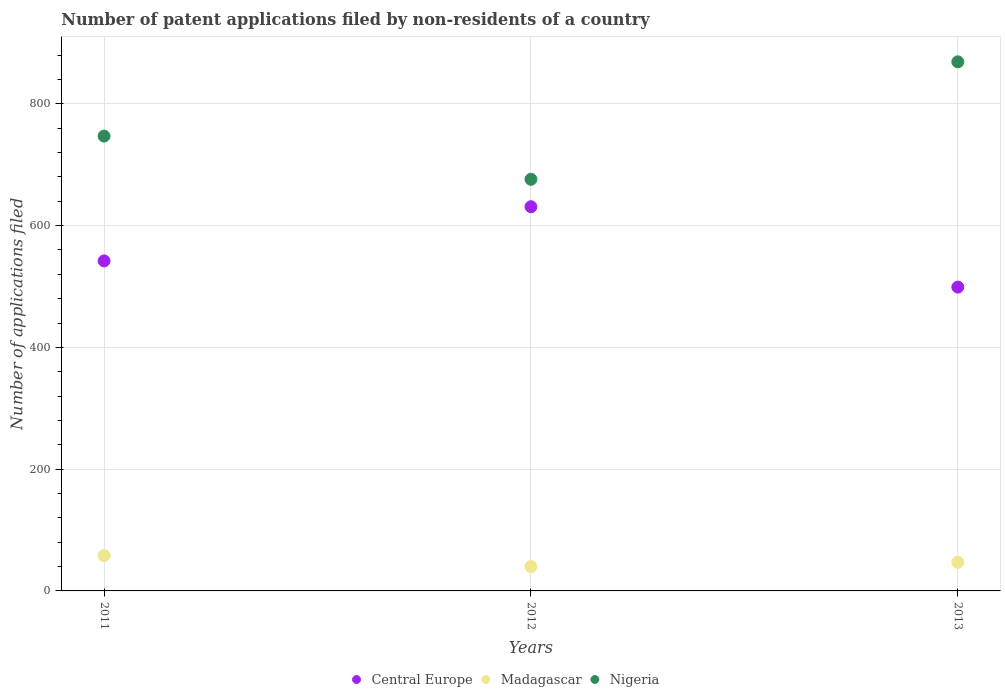How many different coloured dotlines are there?
Provide a succinct answer. 3. What is the number of applications filed in Madagascar in 2011?
Offer a terse response. 58. Across all years, what is the minimum number of applications filed in Nigeria?
Offer a terse response. 676. In which year was the number of applications filed in Nigeria minimum?
Your answer should be very brief. 2012. What is the total number of applications filed in Madagascar in the graph?
Offer a very short reply. 145. What is the difference between the number of applications filed in Madagascar in 2011 and that in 2013?
Offer a very short reply. 11. What is the difference between the number of applications filed in Nigeria in 2011 and the number of applications filed in Madagascar in 2013?
Your response must be concise. 700. What is the average number of applications filed in Central Europe per year?
Ensure brevity in your answer.  557.33. In the year 2013, what is the difference between the number of applications filed in Nigeria and number of applications filed in Central Europe?
Offer a terse response. 370. What is the ratio of the number of applications filed in Nigeria in 2011 to that in 2012?
Offer a terse response. 1.11. Is the number of applications filed in Central Europe in 2011 less than that in 2013?
Provide a succinct answer. No. What is the difference between the highest and the second highest number of applications filed in Nigeria?
Your answer should be very brief. 122. What is the difference between the highest and the lowest number of applications filed in Madagascar?
Offer a very short reply. 18. Is the sum of the number of applications filed in Madagascar in 2011 and 2012 greater than the maximum number of applications filed in Nigeria across all years?
Your answer should be compact. No. Is it the case that in every year, the sum of the number of applications filed in Nigeria and number of applications filed in Central Europe  is greater than the number of applications filed in Madagascar?
Your response must be concise. Yes. Does the number of applications filed in Nigeria monotonically increase over the years?
Provide a succinct answer. No. How many years are there in the graph?
Provide a succinct answer. 3. What is the difference between two consecutive major ticks on the Y-axis?
Offer a very short reply. 200. Does the graph contain grids?
Provide a succinct answer. Yes. Where does the legend appear in the graph?
Provide a succinct answer. Bottom center. How many legend labels are there?
Your response must be concise. 3. What is the title of the graph?
Keep it short and to the point. Number of patent applications filed by non-residents of a country. Does "Palau" appear as one of the legend labels in the graph?
Keep it short and to the point. No. What is the label or title of the Y-axis?
Provide a short and direct response. Number of applications filed. What is the Number of applications filed in Central Europe in 2011?
Offer a terse response. 542. What is the Number of applications filed in Madagascar in 2011?
Ensure brevity in your answer.  58. What is the Number of applications filed in Nigeria in 2011?
Your answer should be very brief. 747. What is the Number of applications filed in Central Europe in 2012?
Give a very brief answer. 631. What is the Number of applications filed in Madagascar in 2012?
Provide a succinct answer. 40. What is the Number of applications filed in Nigeria in 2012?
Your response must be concise. 676. What is the Number of applications filed in Central Europe in 2013?
Your answer should be very brief. 499. What is the Number of applications filed in Nigeria in 2013?
Your answer should be compact. 869. Across all years, what is the maximum Number of applications filed in Central Europe?
Provide a short and direct response. 631. Across all years, what is the maximum Number of applications filed of Madagascar?
Provide a succinct answer. 58. Across all years, what is the maximum Number of applications filed in Nigeria?
Offer a very short reply. 869. Across all years, what is the minimum Number of applications filed in Central Europe?
Offer a very short reply. 499. Across all years, what is the minimum Number of applications filed of Nigeria?
Offer a very short reply. 676. What is the total Number of applications filed of Central Europe in the graph?
Provide a short and direct response. 1672. What is the total Number of applications filed in Madagascar in the graph?
Provide a short and direct response. 145. What is the total Number of applications filed in Nigeria in the graph?
Keep it short and to the point. 2292. What is the difference between the Number of applications filed of Central Europe in 2011 and that in 2012?
Your answer should be very brief. -89. What is the difference between the Number of applications filed in Nigeria in 2011 and that in 2012?
Your answer should be very brief. 71. What is the difference between the Number of applications filed in Nigeria in 2011 and that in 2013?
Your answer should be compact. -122. What is the difference between the Number of applications filed in Central Europe in 2012 and that in 2013?
Make the answer very short. 132. What is the difference between the Number of applications filed in Nigeria in 2012 and that in 2013?
Offer a very short reply. -193. What is the difference between the Number of applications filed in Central Europe in 2011 and the Number of applications filed in Madagascar in 2012?
Offer a terse response. 502. What is the difference between the Number of applications filed of Central Europe in 2011 and the Number of applications filed of Nigeria in 2012?
Provide a succinct answer. -134. What is the difference between the Number of applications filed in Madagascar in 2011 and the Number of applications filed in Nigeria in 2012?
Ensure brevity in your answer.  -618. What is the difference between the Number of applications filed in Central Europe in 2011 and the Number of applications filed in Madagascar in 2013?
Offer a terse response. 495. What is the difference between the Number of applications filed of Central Europe in 2011 and the Number of applications filed of Nigeria in 2013?
Ensure brevity in your answer.  -327. What is the difference between the Number of applications filed in Madagascar in 2011 and the Number of applications filed in Nigeria in 2013?
Keep it short and to the point. -811. What is the difference between the Number of applications filed of Central Europe in 2012 and the Number of applications filed of Madagascar in 2013?
Offer a very short reply. 584. What is the difference between the Number of applications filed in Central Europe in 2012 and the Number of applications filed in Nigeria in 2013?
Provide a short and direct response. -238. What is the difference between the Number of applications filed in Madagascar in 2012 and the Number of applications filed in Nigeria in 2013?
Make the answer very short. -829. What is the average Number of applications filed in Central Europe per year?
Provide a succinct answer. 557.33. What is the average Number of applications filed in Madagascar per year?
Provide a succinct answer. 48.33. What is the average Number of applications filed in Nigeria per year?
Provide a short and direct response. 764. In the year 2011, what is the difference between the Number of applications filed of Central Europe and Number of applications filed of Madagascar?
Your response must be concise. 484. In the year 2011, what is the difference between the Number of applications filed in Central Europe and Number of applications filed in Nigeria?
Give a very brief answer. -205. In the year 2011, what is the difference between the Number of applications filed of Madagascar and Number of applications filed of Nigeria?
Your answer should be very brief. -689. In the year 2012, what is the difference between the Number of applications filed in Central Europe and Number of applications filed in Madagascar?
Keep it short and to the point. 591. In the year 2012, what is the difference between the Number of applications filed in Central Europe and Number of applications filed in Nigeria?
Your answer should be very brief. -45. In the year 2012, what is the difference between the Number of applications filed in Madagascar and Number of applications filed in Nigeria?
Your answer should be compact. -636. In the year 2013, what is the difference between the Number of applications filed of Central Europe and Number of applications filed of Madagascar?
Your answer should be compact. 452. In the year 2013, what is the difference between the Number of applications filed of Central Europe and Number of applications filed of Nigeria?
Give a very brief answer. -370. In the year 2013, what is the difference between the Number of applications filed in Madagascar and Number of applications filed in Nigeria?
Provide a succinct answer. -822. What is the ratio of the Number of applications filed of Central Europe in 2011 to that in 2012?
Offer a terse response. 0.86. What is the ratio of the Number of applications filed in Madagascar in 2011 to that in 2012?
Your response must be concise. 1.45. What is the ratio of the Number of applications filed of Nigeria in 2011 to that in 2012?
Offer a very short reply. 1.1. What is the ratio of the Number of applications filed of Central Europe in 2011 to that in 2013?
Provide a short and direct response. 1.09. What is the ratio of the Number of applications filed of Madagascar in 2011 to that in 2013?
Your response must be concise. 1.23. What is the ratio of the Number of applications filed of Nigeria in 2011 to that in 2013?
Your answer should be very brief. 0.86. What is the ratio of the Number of applications filed of Central Europe in 2012 to that in 2013?
Provide a short and direct response. 1.26. What is the ratio of the Number of applications filed of Madagascar in 2012 to that in 2013?
Your response must be concise. 0.85. What is the ratio of the Number of applications filed of Nigeria in 2012 to that in 2013?
Offer a terse response. 0.78. What is the difference between the highest and the second highest Number of applications filed in Central Europe?
Your answer should be very brief. 89. What is the difference between the highest and the second highest Number of applications filed in Nigeria?
Provide a short and direct response. 122. What is the difference between the highest and the lowest Number of applications filed of Central Europe?
Your response must be concise. 132. What is the difference between the highest and the lowest Number of applications filed in Nigeria?
Your response must be concise. 193. 